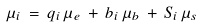Convert formula to latex. <formula><loc_0><loc_0><loc_500><loc_500>\mu _ { i } \, = \, q _ { i } \, \mu _ { e } \, + \, b _ { i } \, \mu _ { b } \, + \, S _ { i } \, \mu _ { s }</formula> 